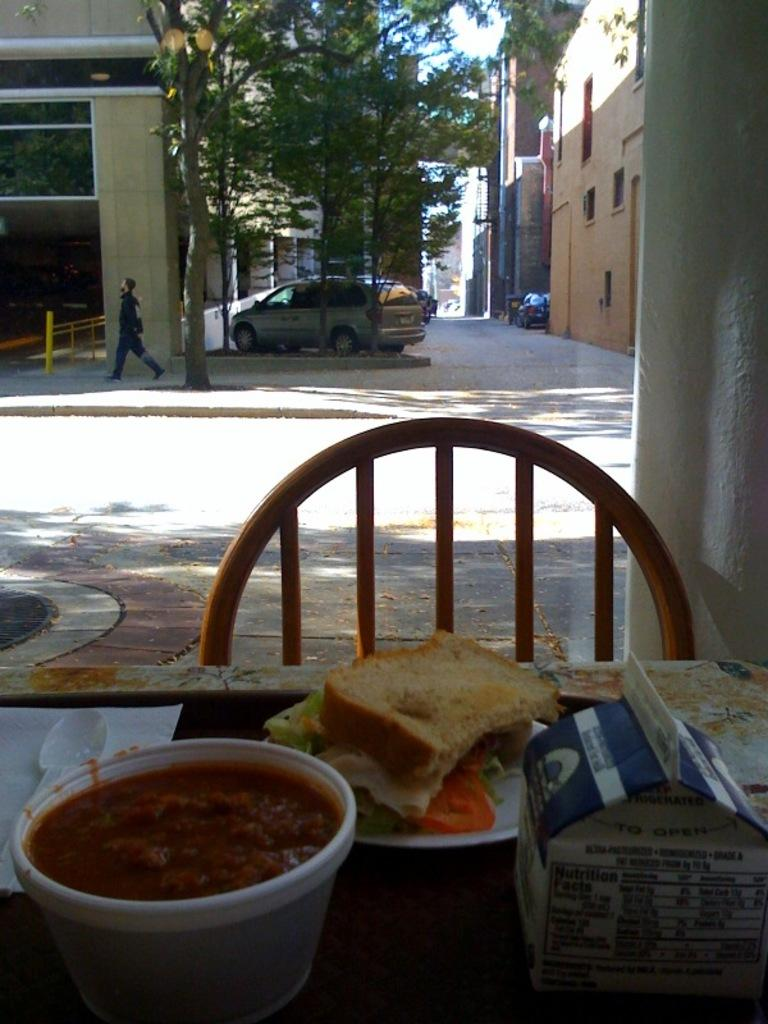What type of food can be seen in the image? There is food in the image, including bread. What utensil is present in the image? There is a spoon in the image. What object is on the table in the image? There is a box on the table in the image. What can be seen in the background of the image? In the background, there are buildings, trees, and cars visible. What instrument is the man playing in the background of the image? There is no man playing an instrument in the image; he is simply walking in the background. What book is the man reading in the image? There is no man reading a book in the image; he is walking in the background. 